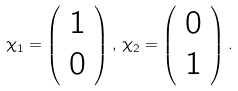<formula> <loc_0><loc_0><loc_500><loc_500>\chi _ { 1 } = \left ( \begin{array} { c c } 1 \\ 0 \end{array} \right ) , \, \chi _ { 2 } = \left ( \begin{array} { c c } 0 \\ 1 \end{array} \right ) .</formula> 